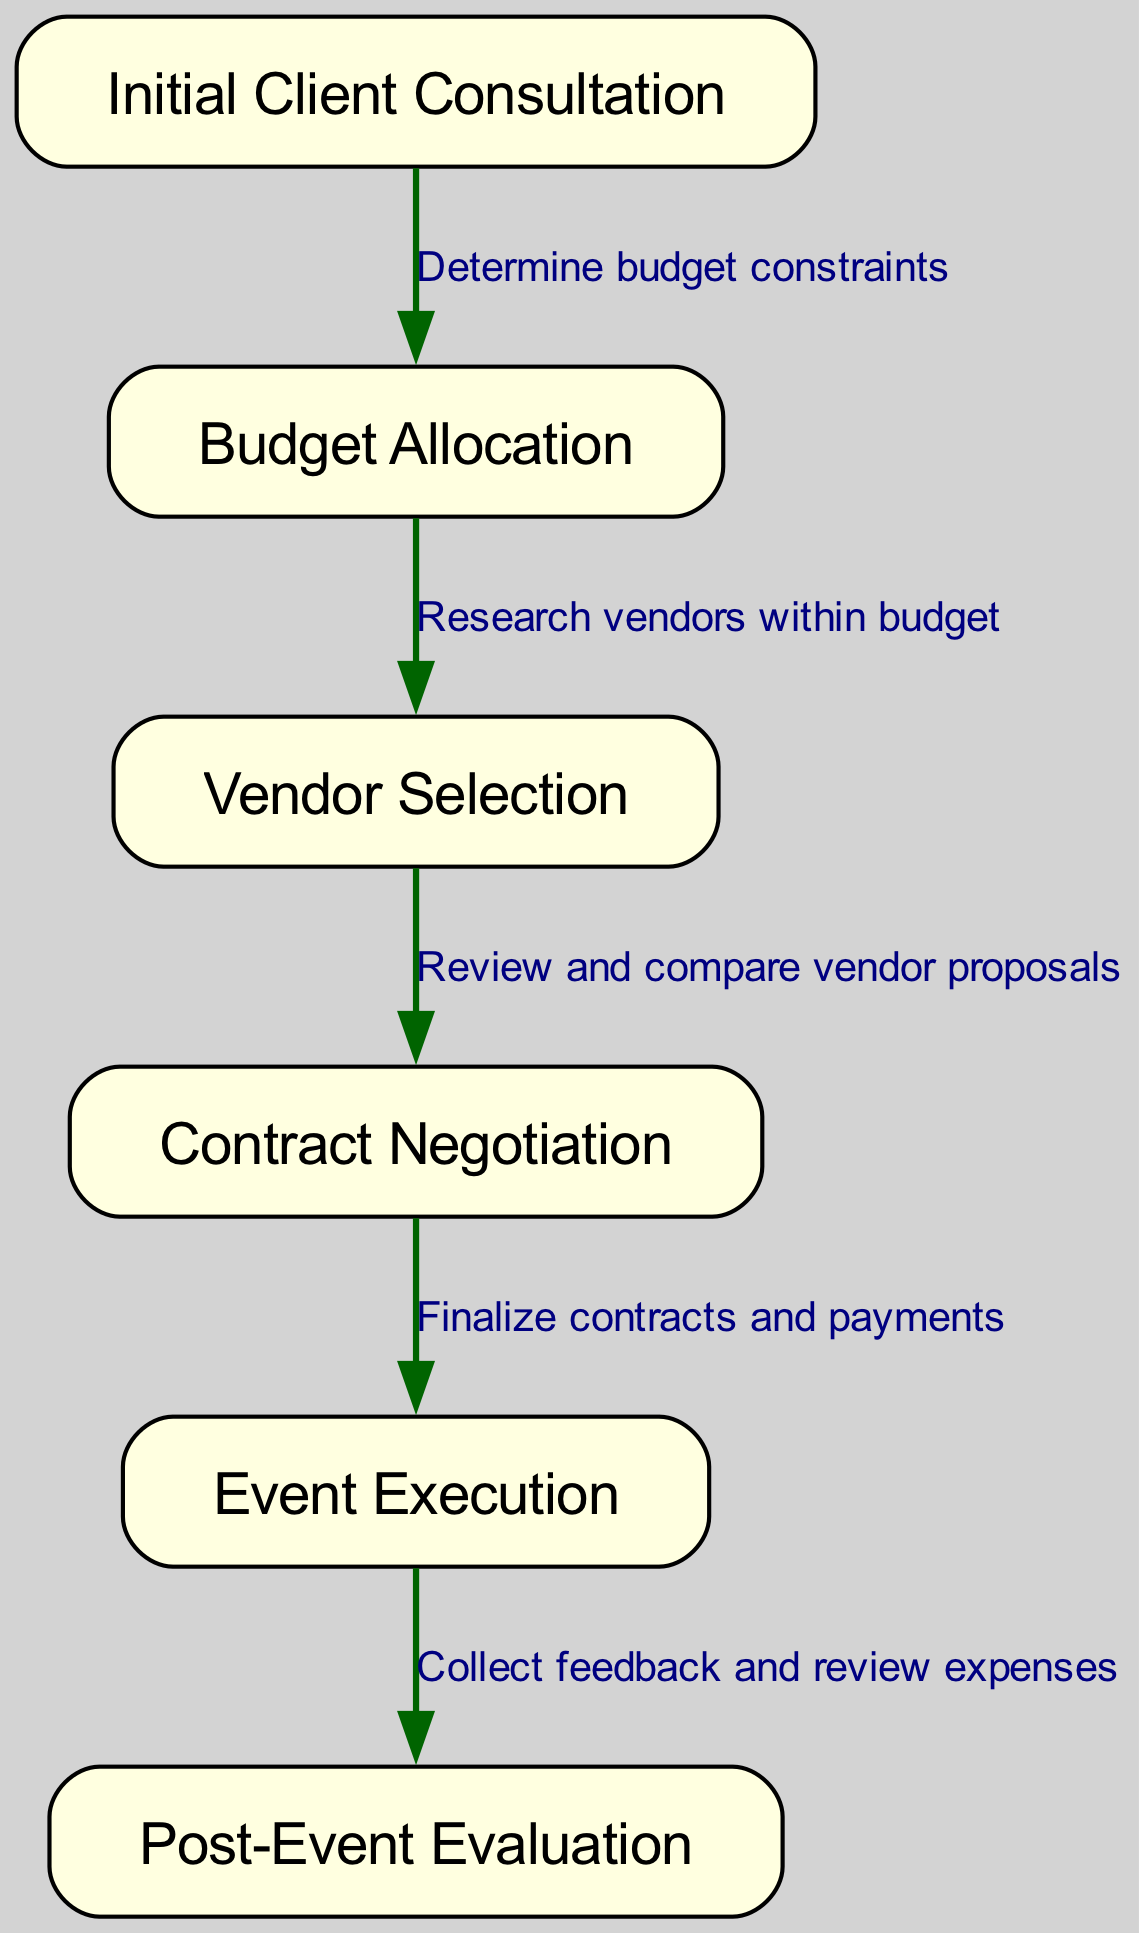What is the first step in the event planning process? The diagram shows that the first step in the event planning process is represented by the node labeled 'Initial Client Consultation.'
Answer: Initial Client Consultation How many nodes are in the diagram? By counting the nodes listed in the data, there are a total of six nodes in the diagram: Initial Client Consultation, Budget Allocation, Vendor Selection, Contract Negotiation, Event Execution, and Post-Event Evaluation.
Answer: 6 What is the relationship between 'Budget Allocation' and 'Vendor Selection'? The edge connecting 'Budget Allocation' to 'Vendor Selection' indicates that by researching vendors within the allocated budget, the selection of vendors is performed.
Answer: Research vendors within budget Which step comes immediately after 'Contract Negotiation'? Following the edge from 'Contract Negotiation', the next step indicated is 'Event Execution'. Therefore, the immediate next step is 'Event Execution'.
Answer: Event Execution What is the final step in the event planning clinical pathway? The last node in the diagram, which concludes the process, is marked as 'Post-Event Evaluation.'
Answer: Post-Event Evaluation How does 'Initial Client Consultation' influence 'Budget Allocation'? The edge indicates that during the 'Initial Client Consultation', the budget constraints are determined, which directly influences the subsequent step of allocation.
Answer: Determine budget constraints What action is taken after 'Event Execution'? The edge leading from 'Event Execution' to 'Post-Event Evaluation' showcases that feedback is collected and expenses are reviewed after the event has been executed.
Answer: Collect feedback and review expenses What is the total number of edges in the diagram? By examining the connections between nodes, it can be noted that there are five edges represented in the diagram.
Answer: 5 